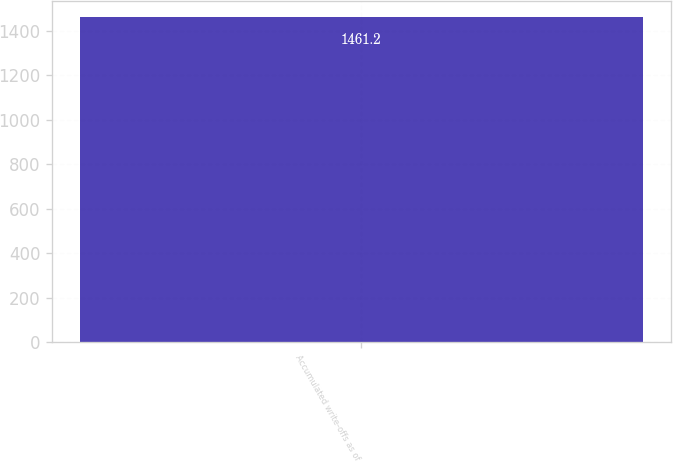<chart> <loc_0><loc_0><loc_500><loc_500><bar_chart><fcel>Accumulated write-offs as of<nl><fcel>1461.2<nl></chart> 